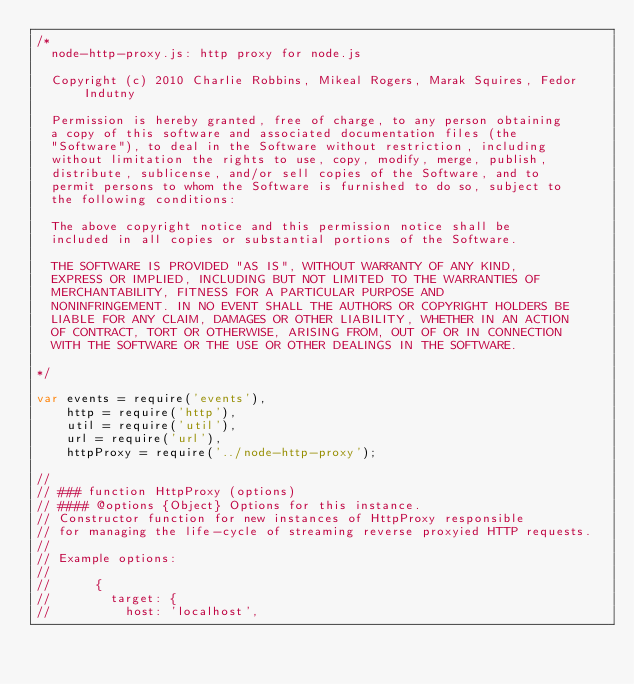<code> <loc_0><loc_0><loc_500><loc_500><_JavaScript_>/*
  node-http-proxy.js: http proxy for node.js

  Copyright (c) 2010 Charlie Robbins, Mikeal Rogers, Marak Squires, Fedor Indutny

  Permission is hereby granted, free of charge, to any person obtaining
  a copy of this software and associated documentation files (the
  "Software"), to deal in the Software without restriction, including
  without limitation the rights to use, copy, modify, merge, publish,
  distribute, sublicense, and/or sell copies of the Software, and to
  permit persons to whom the Software is furnished to do so, subject to
  the following conditions:

  The above copyright notice and this permission notice shall be
  included in all copies or substantial portions of the Software.

  THE SOFTWARE IS PROVIDED "AS IS", WITHOUT WARRANTY OF ANY KIND,
  EXPRESS OR IMPLIED, INCLUDING BUT NOT LIMITED TO THE WARRANTIES OF
  MERCHANTABILITY, FITNESS FOR A PARTICULAR PURPOSE AND
  NONINFRINGEMENT. IN NO EVENT SHALL THE AUTHORS OR COPYRIGHT HOLDERS BE
  LIABLE FOR ANY CLAIM, DAMAGES OR OTHER LIABILITY, WHETHER IN AN ACTION
  OF CONTRACT, TORT OR OTHERWISE, ARISING FROM, OUT OF OR IN CONNECTION
  WITH THE SOFTWARE OR THE USE OR OTHER DEALINGS IN THE SOFTWARE.

*/

var events = require('events'),
    http = require('http'),
    util = require('util'),
    url = require('url'),
    httpProxy = require('../node-http-proxy');

//
// ### function HttpProxy (options)
// #### @options {Object} Options for this instance.
// Constructor function for new instances of HttpProxy responsible
// for managing the life-cycle of streaming reverse proxyied HTTP requests.
//
// Example options:
//
//      {
//        target: {
//          host: 'localhost',</code> 